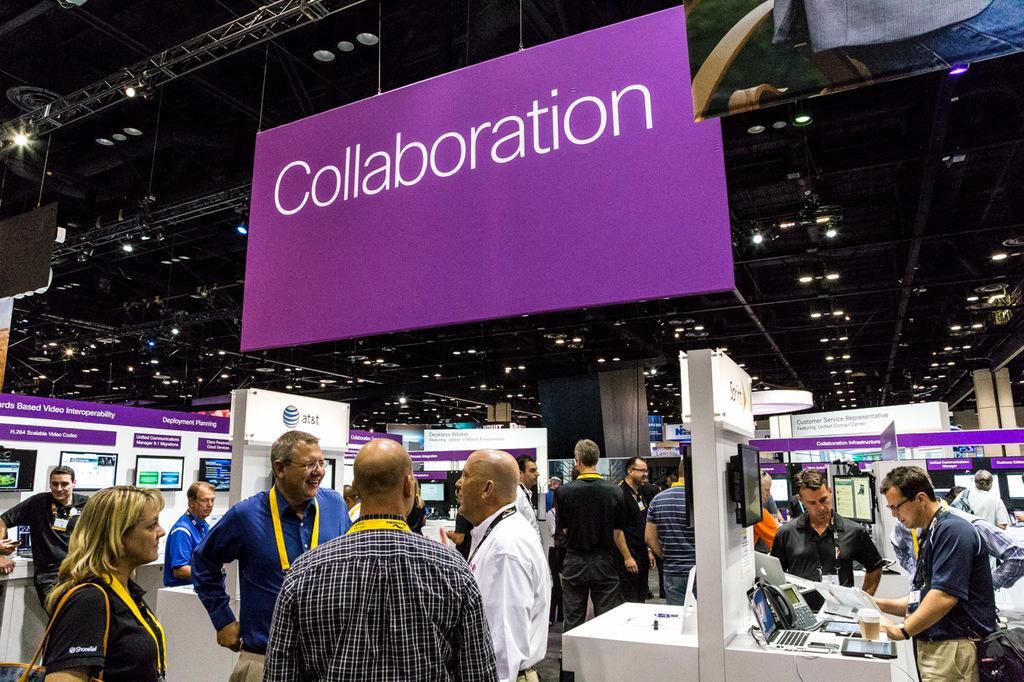Can you describe this image briefly? Many people are present. There are telephones and other objects. There is a board hanging. There are lights on the top. 